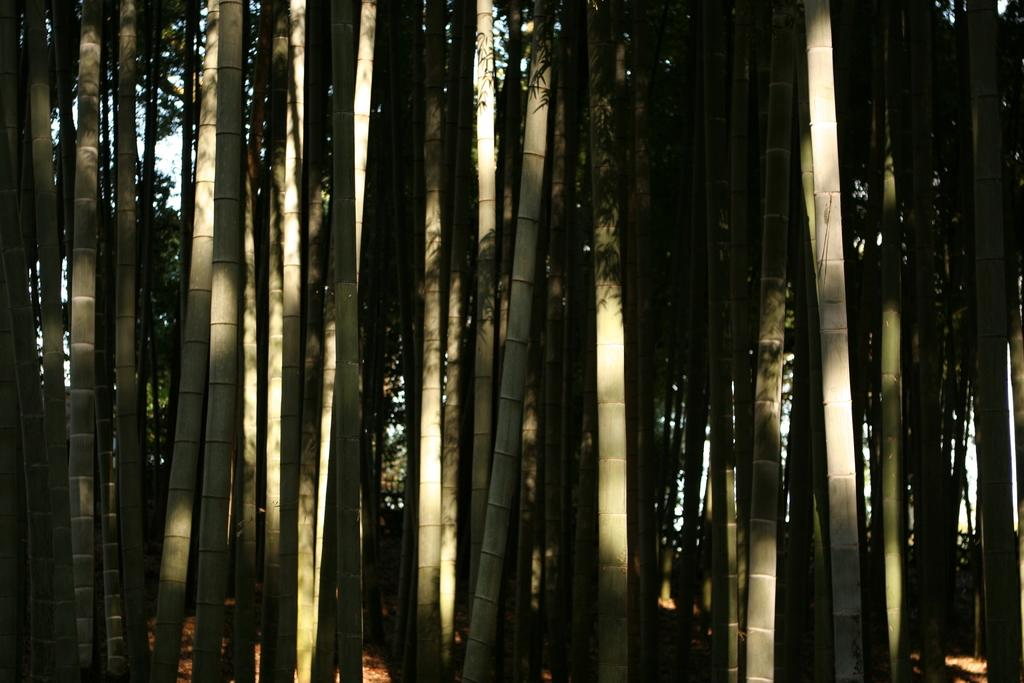What type of natural objects can be seen in the image? There are many sticks of trees in the image. Can you describe the background of the image? There are trees and the sky visible in the background of the image. What type of jar can be seen on the chessboard in the image? There is no jar or chessboard present in the image. Is there a scarf hanging from one of the trees in the image? There is no scarf visible in the image; only trees and the sky are present in the background. 